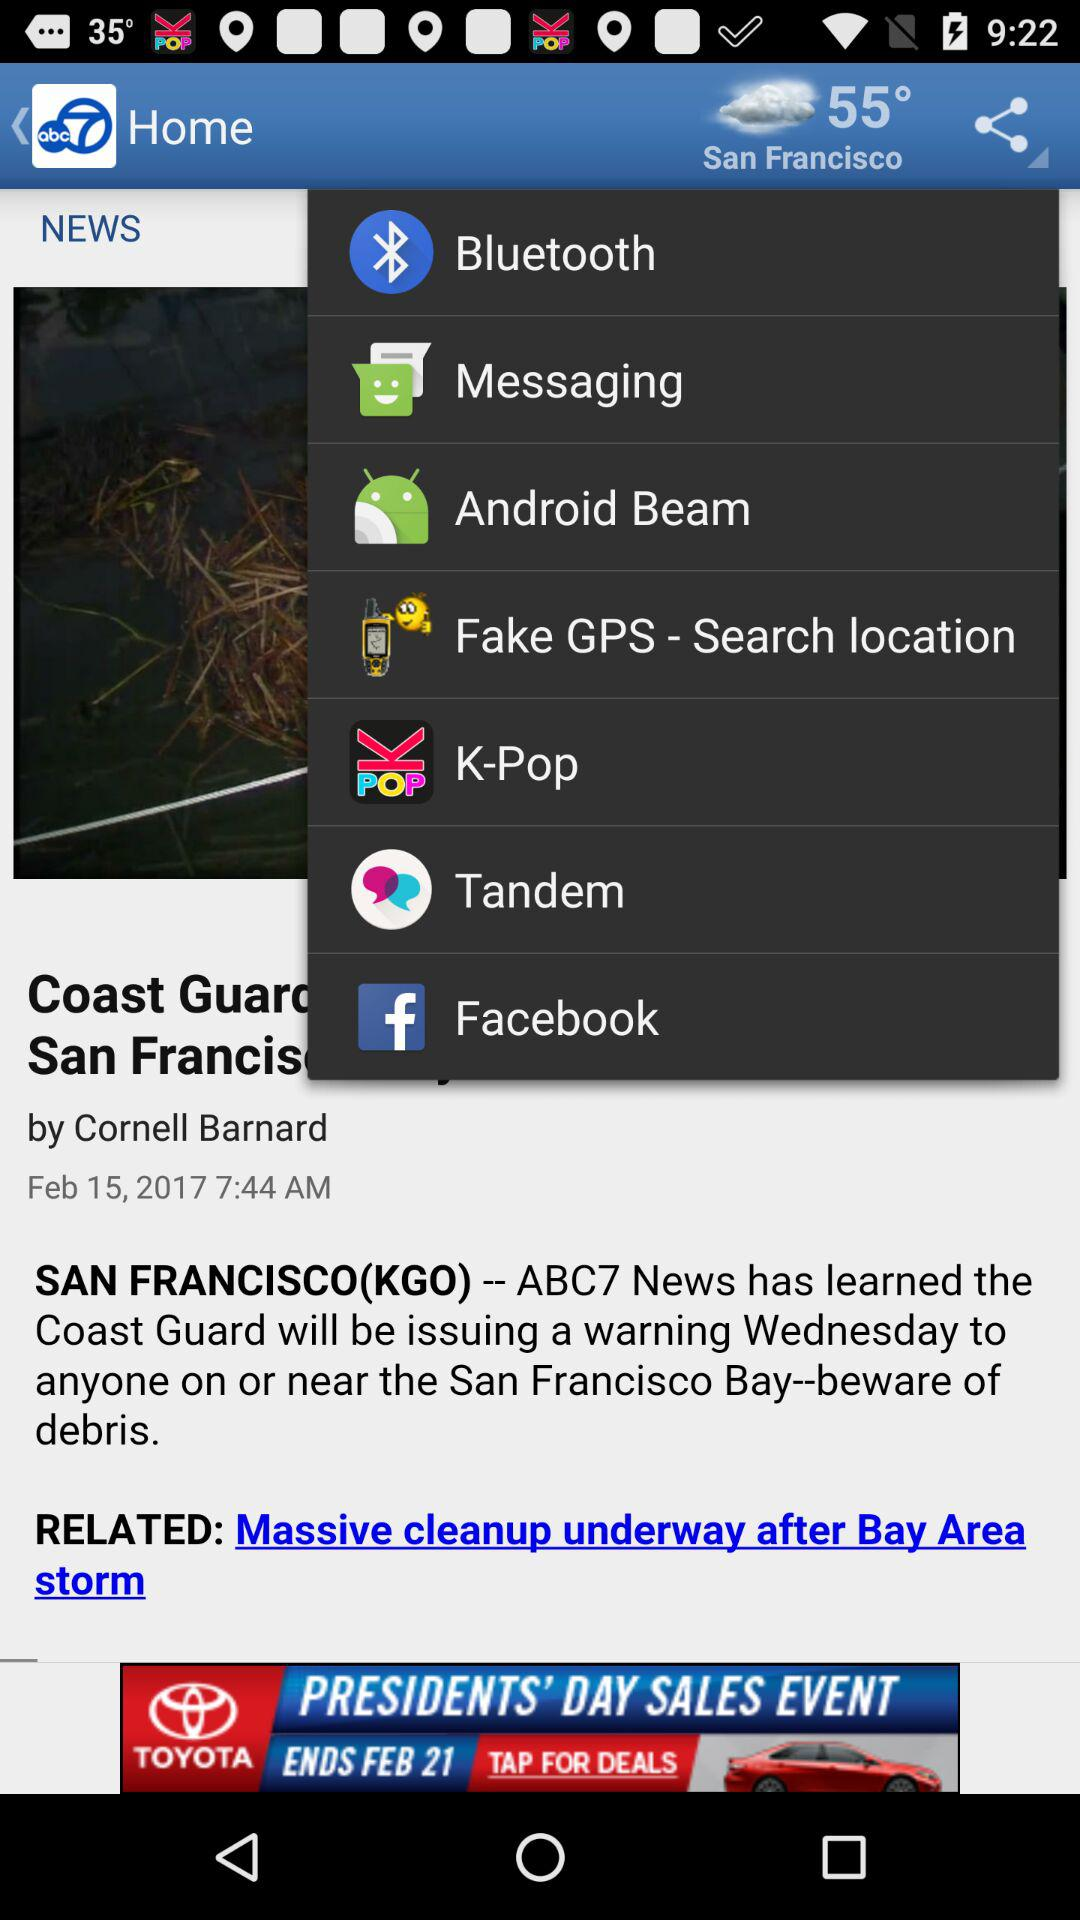How is the weather in San Francisco? The weather is cloudy. 